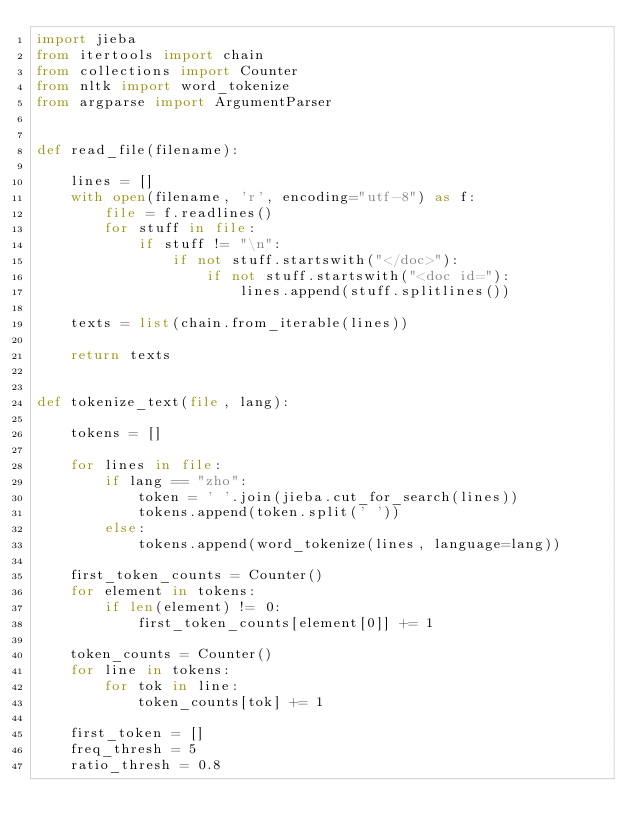<code> <loc_0><loc_0><loc_500><loc_500><_Python_>import jieba
from itertools import chain
from collections import Counter
from nltk import word_tokenize
from argparse import ArgumentParser


def read_file(filename):

    lines = []
    with open(filename, 'r', encoding="utf-8") as f:
        file = f.readlines()
        for stuff in file:
            if stuff != "\n":
                if not stuff.startswith("</doc>"):
                    if not stuff.startswith("<doc id="):
                        lines.append(stuff.splitlines())

    texts = list(chain.from_iterable(lines))

    return texts


def tokenize_text(file, lang):

    tokens = []

    for lines in file:
        if lang == "zho":
            token = ' '.join(jieba.cut_for_search(lines))
            tokens.append(token.split(' '))
        else:
            tokens.append(word_tokenize(lines, language=lang))

    first_token_counts = Counter()
    for element in tokens:
        if len(element) != 0:
            first_token_counts[element[0]] += 1

    token_counts = Counter()
    for line in tokens:
        for tok in line:
            token_counts[tok] += 1

    first_token = []
    freq_thresh = 5
    ratio_thresh = 0.8
</code> 